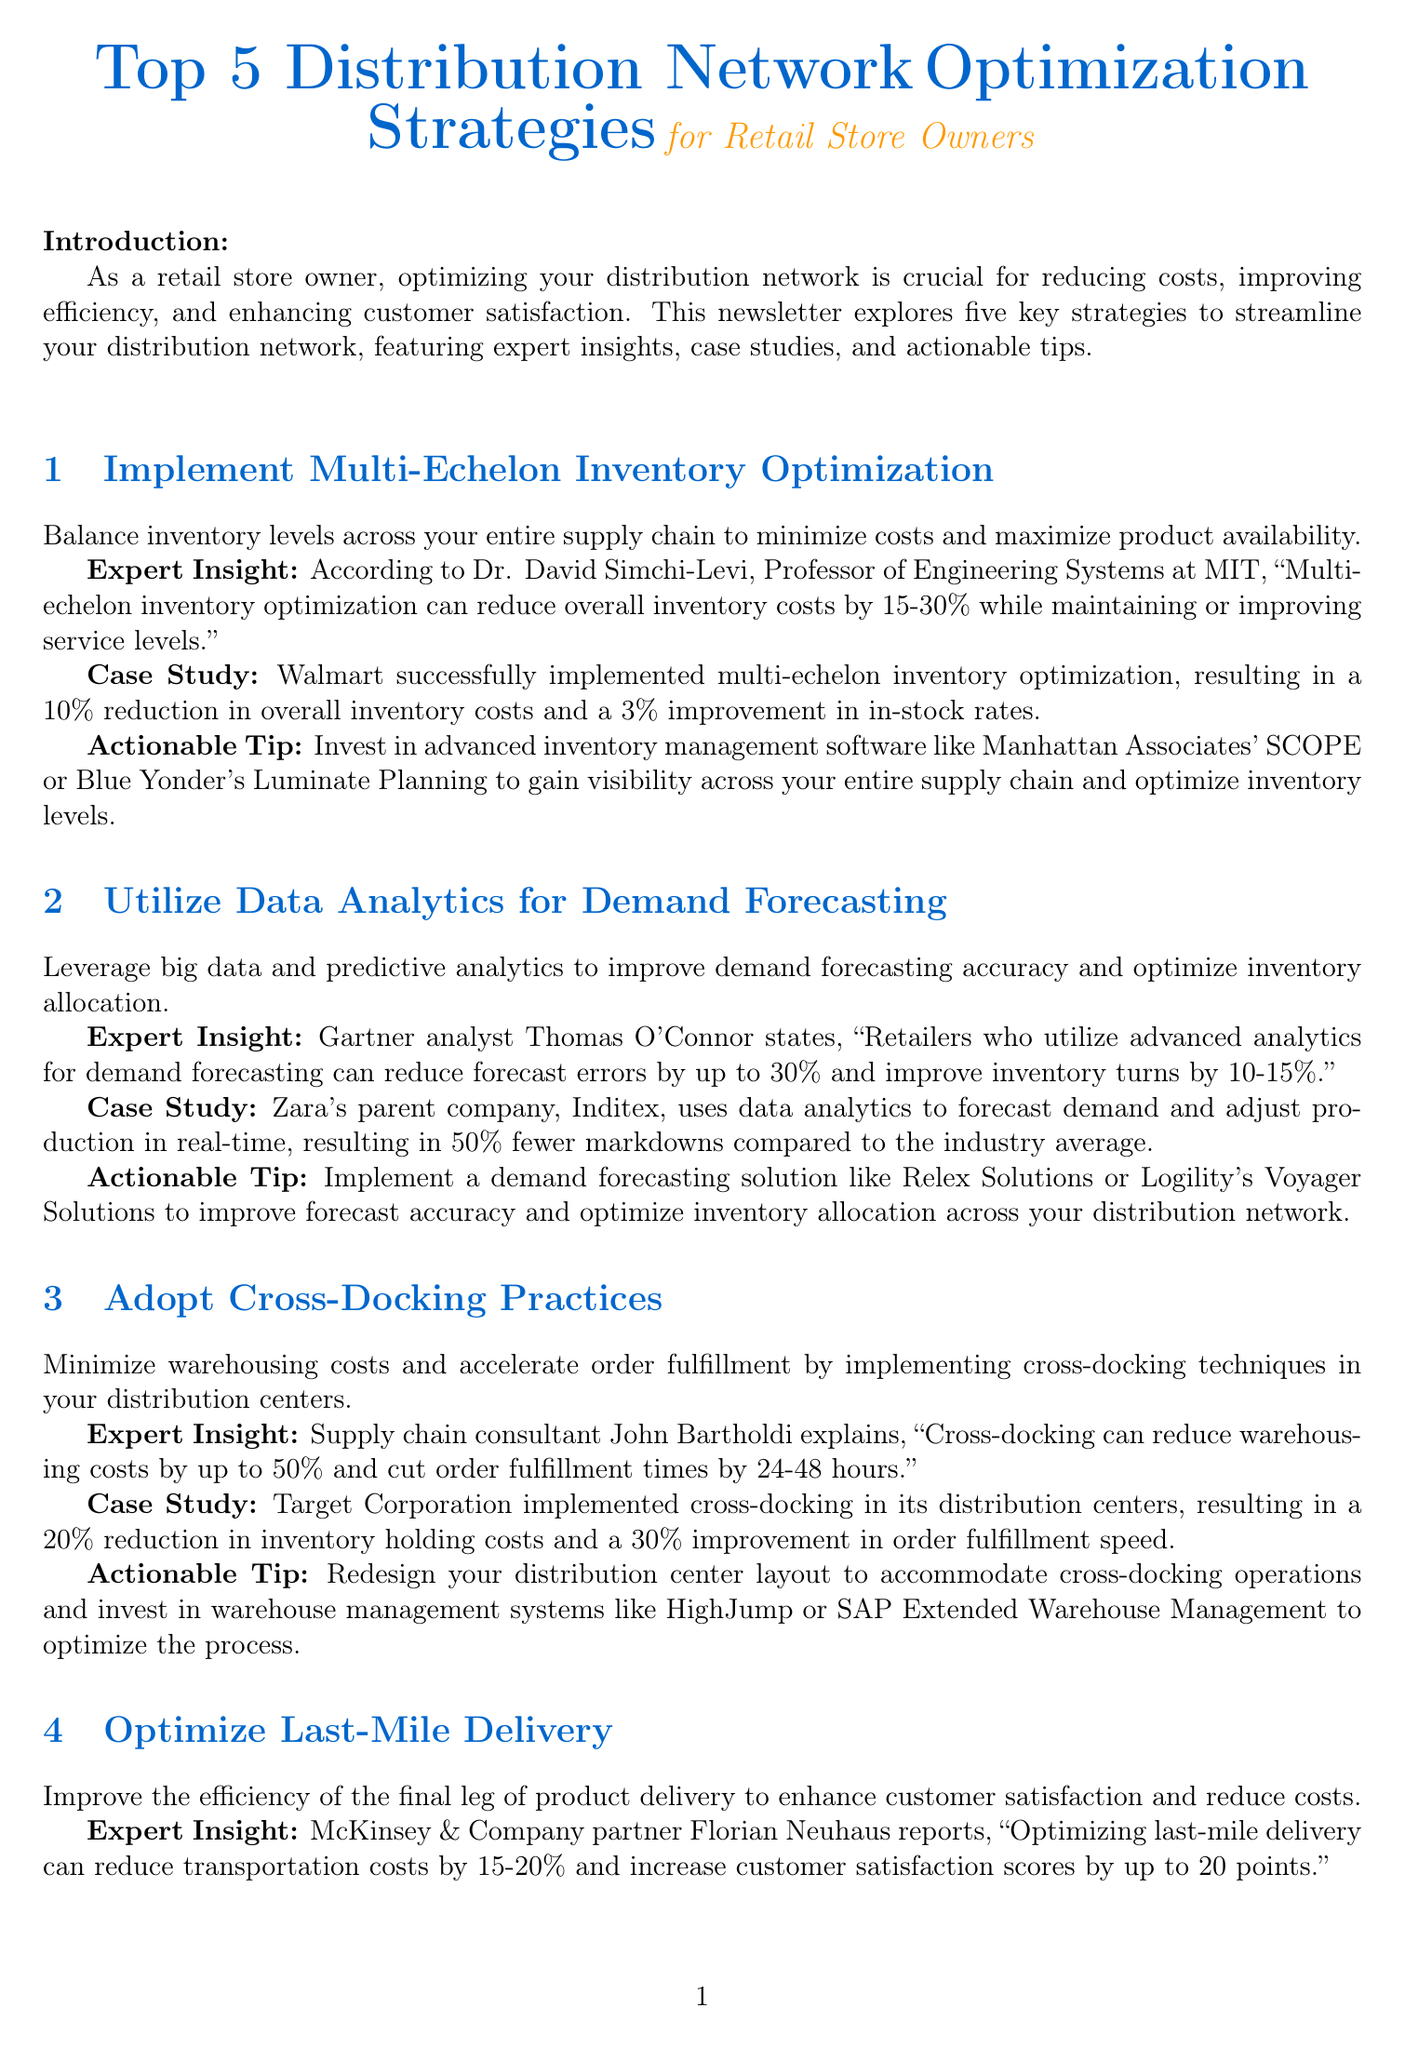What is the title of the newsletter? The title is specified at the beginning of the document as "Top 5 Distribution Network Optimization Strategies for Retail Store Owners."
Answer: Top 5 Distribution Network Optimization Strategies for Retail Store Owners Who provided the expert insight for Multi-Echelon Inventory Optimization? The document explicitly mentions Dr. David Simchi-Levi as the expert providing insights on this strategy.
Answer: Dr. David Simchi-Levi What percentage reduction in inventory costs did Walmart achieve? According to the case study, Walmart achieved a 10% reduction in overall inventory costs by implementing the strategy.
Answer: 10% What can adopting cross-docking practices reduce by up to 50%? The expert insight regarding cross-docking mentions that it can reduce warehousing costs by up to 50%.
Answer: Warehousing costs Which company implemented Vendor-Managed Inventory with key suppliers? Home Depot is specifically mentioned in the document as the company that implemented VMI with its key suppliers.
Answer: Home Depot What is one actionable tip for optimizing last-mile delivery? The document suggests partnering with last-mile delivery optimization platforms like Bringg or Onfleet as an actionable tip.
Answer: Bringg or Onfleet How much can optimizing last-mile delivery potentially increase customer satisfaction scores? According to the expert insight, optimizing last-mile delivery could increase customer satisfaction scores by up to 20 points.
Answer: 20 points What is a key benefit mentioned for utilizing data analytics for demand forecasting? The document states that retailers using advanced analytics can reduce forecast errors by up to 30%.
Answer: 30% 